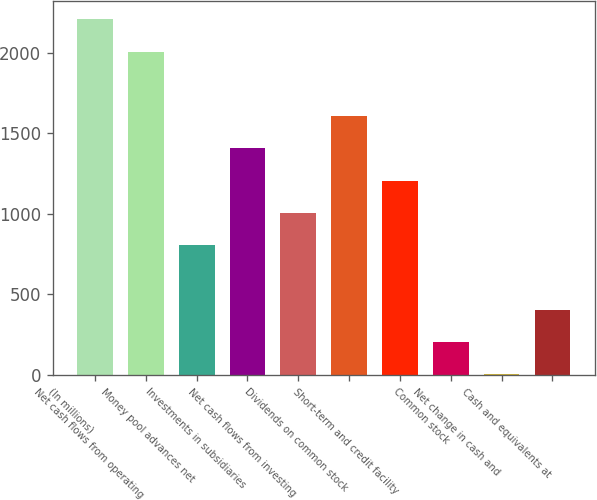Convert chart to OTSL. <chart><loc_0><loc_0><loc_500><loc_500><bar_chart><fcel>(In millions)<fcel>Net cash flows from operating<fcel>Money pool advances net<fcel>Investments in subsidiaries<fcel>Net cash flows from investing<fcel>Dividends on common stock<fcel>Short-term and credit facility<fcel>Common stock<fcel>Net change in cash and<fcel>Cash and equivalents at<nl><fcel>2207.3<fcel>2007<fcel>805.2<fcel>1406.1<fcel>1005.5<fcel>1606.4<fcel>1205.8<fcel>204.3<fcel>4<fcel>404.6<nl></chart> 